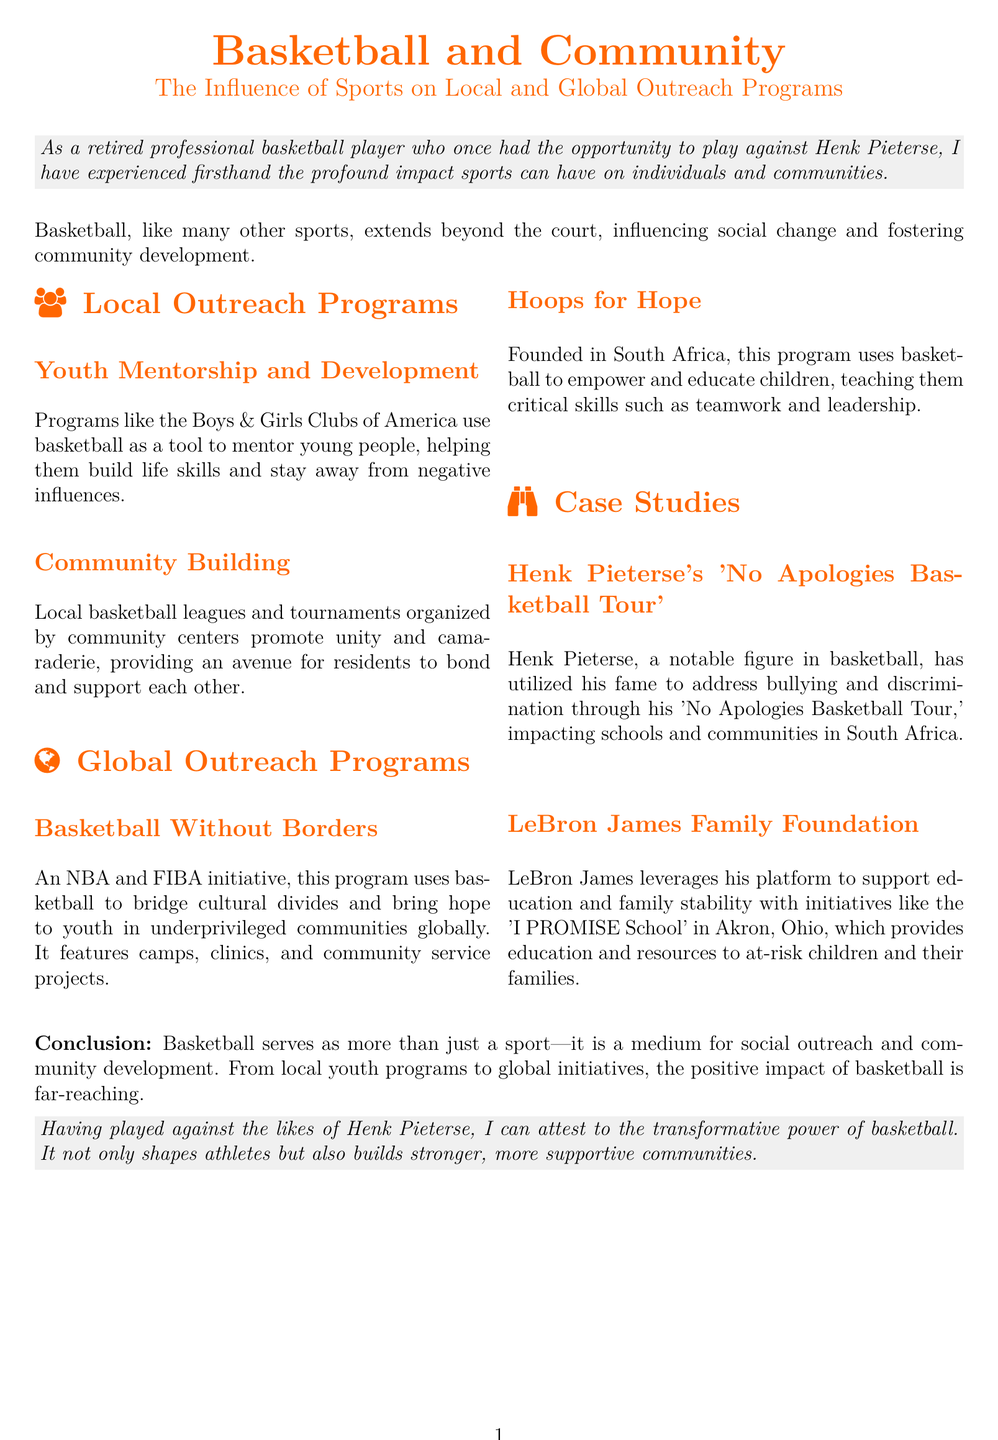What is the title of the document? The title is provided at the beginning of the document, indicating the main topic being discussed.
Answer: Basketball and Community Which program uses basketball to mentor young people? The document mentions specific programs focused on youth mentorship using basketball as a tool.
Answer: Boys & Girls Clubs of America What global initiative is associated with the NBA and FIBA? This initiative aims to use basketball for cultural exchange and outreach globally.
Answer: Basketball Without Borders Who founded the Hoops for Hope program? The document states who established this specific program aimed at empowering children through basketball.
Answer: South Africa What social issue does Henk Pieterse's tour address? The document describes the main focus of Henk Pieterse’s tour in relation to societal challenges.
Answer: Bullying and discrimination What is the name of LeBron James's school initiative? This is a notable education-related effort linked to LeBron James mentioned in the document.
Answer: I PROMISE School What is the primary purpose of local basketball leagues? The document outlines the main intention behind organizing local basketball events within communities.
Answer: Unity and camaraderie How does basketball serve communities according to the document? The conclusion summarizes the broader impact that the sport has on various social aspects.
Answer: Medium for social outreach 